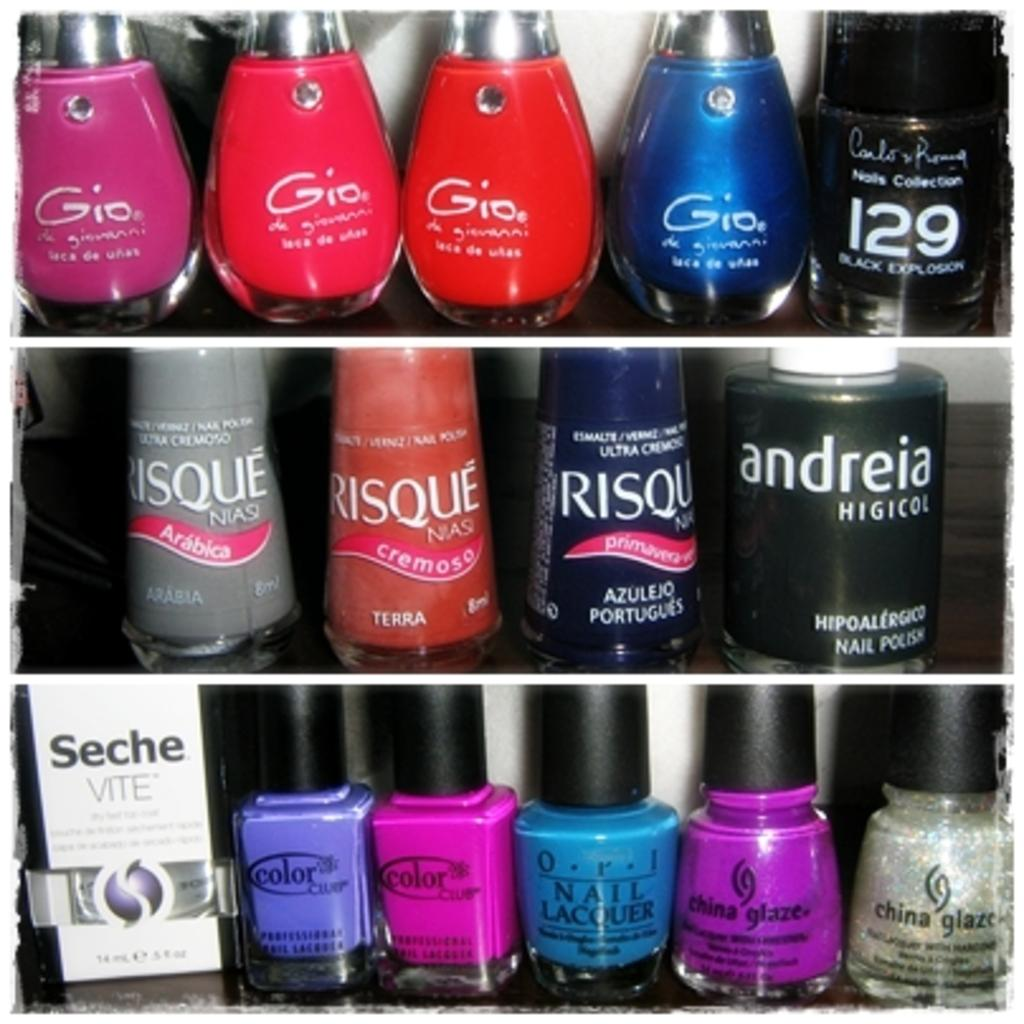What objects are visible in the image? There are bottles in the image. Where are the bottles located? The bottles are inside a shelf. What can be seen on the bottles? There is text written on the bottles. What is the condition of the cent on the ring in the image? There is no cent or ring present in the image. 